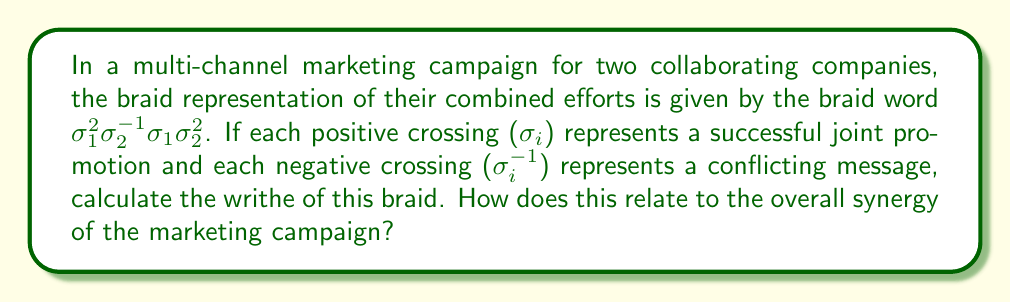Solve this math problem. To solve this problem, we'll follow these steps:

1) Recall that the writhe of a braid is the sum of the signs of all crossings, where:
   - Positive crossings ($\sigma_i$) contribute +1
   - Negative crossings ($\sigma_i^{-1}$) contribute -1

2) Analyze the given braid word: $\sigma_1^2\sigma_2^{-1}\sigma_1\sigma_2^2$

3) Count the contributions:
   - $\sigma_1^2$: Two positive crossings, +2
   - $\sigma_2^{-1}$: One negative crossing, -1
   - $\sigma_1$: One positive crossing, +1
   - $\sigma_2^2$: Two positive crossings, +2

4) Sum up all contributions:
   $(+2) + (-1) + (+1) + (+2) = 4$

5) Therefore, the writhe of the braid is 4.

6) Interpretation for the marketing campaign:
   - Positive writhe indicates more successful joint promotions than conflicting messages
   - The magnitude (4) suggests a strong overall synergy between the companies
   - This implies that the collaboration is likely to be beneficial for both parties, with aligned messaging outweighing conflicts
Answer: Writhe = 4, indicating strong positive synergy in the marketing campaign. 